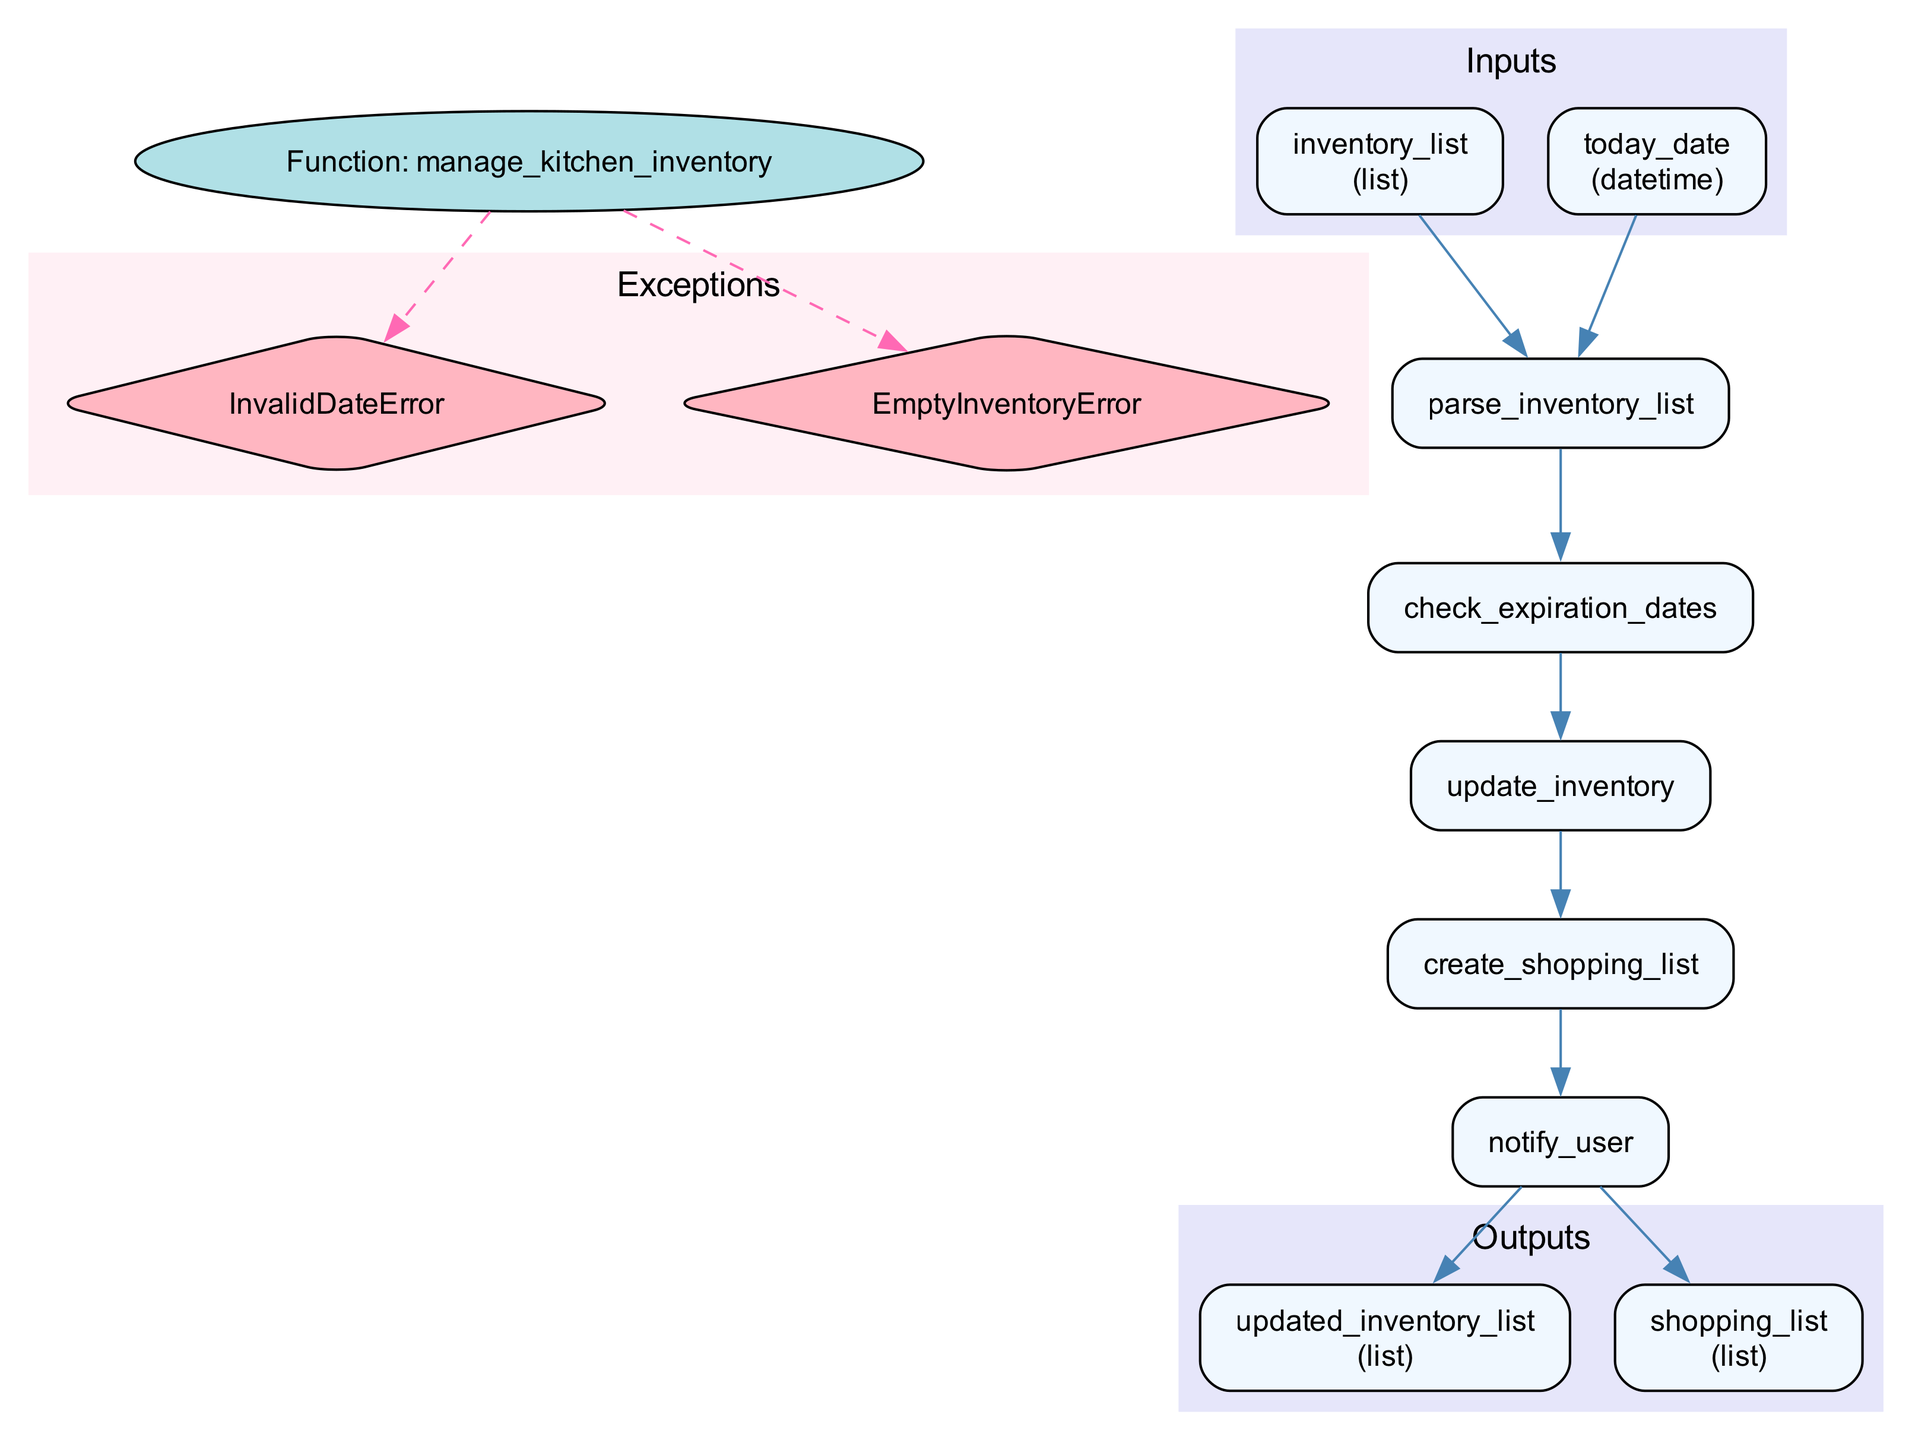What is the name of the function represented in the diagram? The diagram explicitly states the function name at the beginning labeled as "Function: manage_kitchen_inventory".
Answer: manage_kitchen_inventory What type of data does the input 'inventory_list' consist of? The input section describes 'inventory_list' as a list that contains kitchen supplies along with their expiration dates and quantities.
Answer: list How many processes are involved in this function? By counting the processes listed in the diagram, there are five processes: parse_inventory_list, check_expiration_dates, update_inventory, create_shopping_list, and notify_user.
Answer: five What is the output after the process of updating the inventory? According to the outputs section, the first output is "updated_inventory_list", which represents the list of kitchen supplies with updated quantities and removed expired items.
Answer: updated_inventory_list Which process generates a shopping list? The process named "create_shopping_list" is responsible for generating a shopping list for items that are low in stock or expired, as stated in the processes section.
Answer: create_shopping_list How are expired items identified in the inventory? The process "check_expiration_dates" is specifically designed to compare each item's expiration date with the current date and flag any expired items accordingly.
Answer: check_expiration_dates What type of error is raised if the inventory list is empty? The exceptions section indicates that an "EmptyInventoryError" is raised when there is an empty inventory list.
Answer: EmptyInventoryError How do the inputs connect to the first process? The inputs connect to the first process, "parse_inventory_list", through edges that indicate the flow of data from each input node directly to this first process node.
Answer: two connections What color is used for the nodes representing exceptions? The exception nodes are filled with the color '#FFB6C1', which can be identified from the diagram's exception section that explicitly states this color for those nodes.
Answer: '#FFB6C1' 